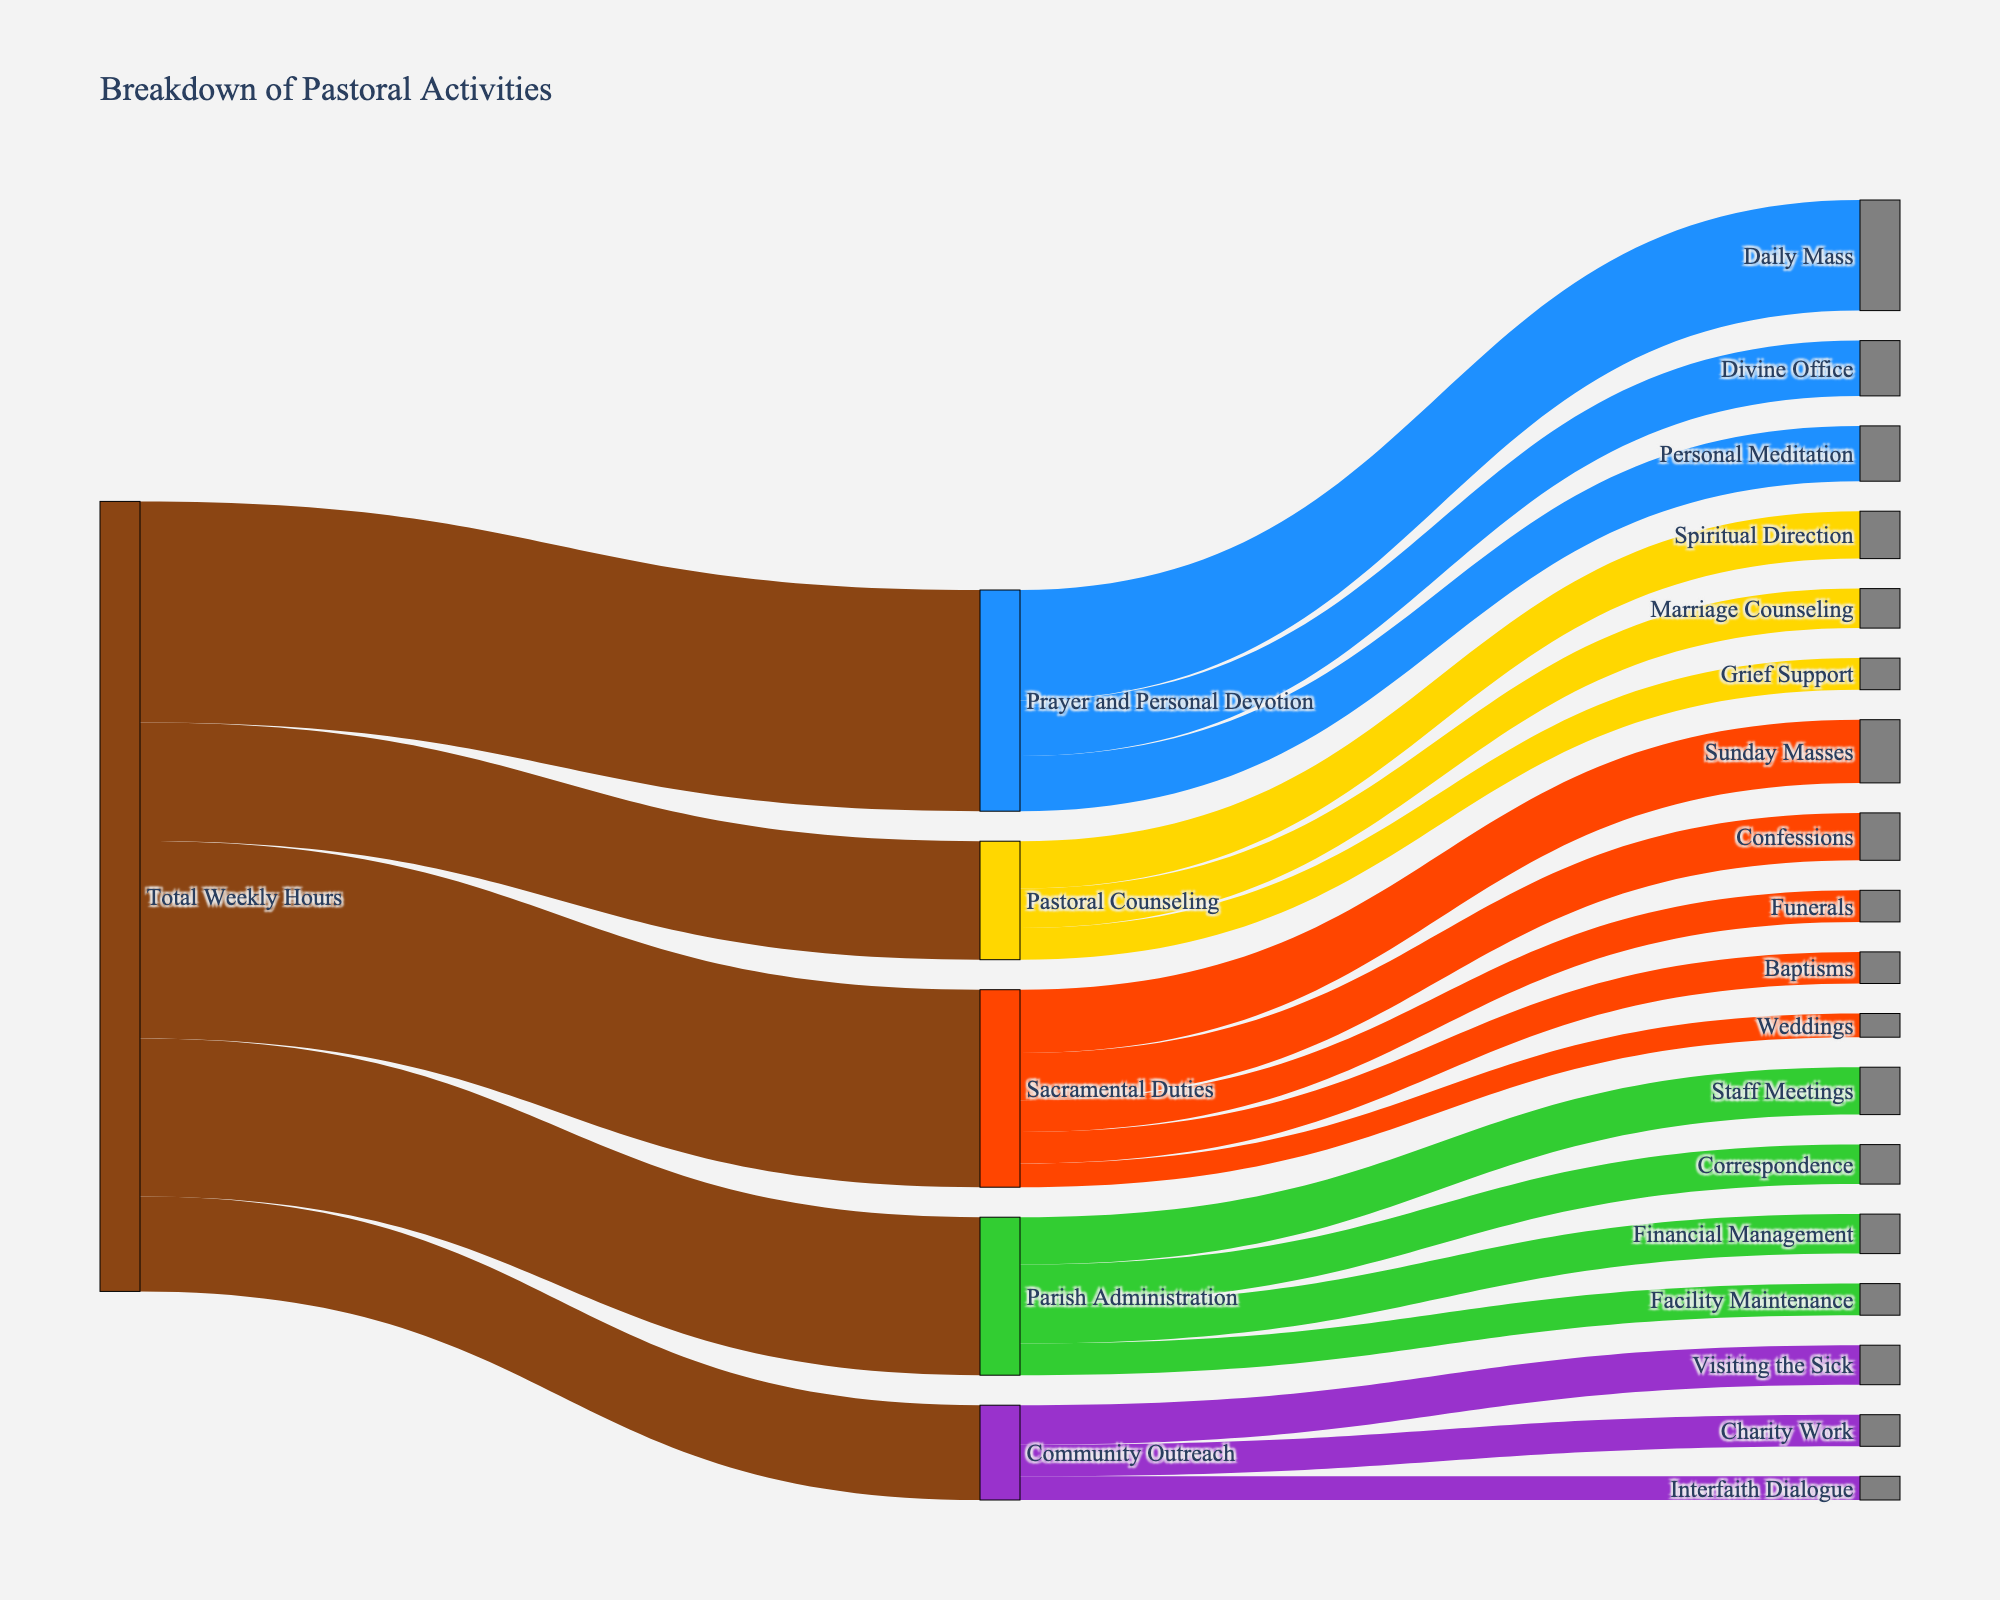What is the total amount of time spent on Prayer and Personal Devotion? According to the Sankey diagram, the Total Weekly Hours directed to Prayer and Personal Devotion is 28 hours.
Answer: 28 hours Which activity under Sacramental Duties takes the most time? In the Sankey diagram, Sunday Masses takes the most time under Sacramental Duties with 8 hours.
Answer: Sunday Masses How many hours are spent on Community Outreach activities in total? The times for Visiting the Sick, Charity Work, and Interfaith Dialogue are 5 hours, 4 hours, and 3 hours respectively. Summing these gives 5+4+3 = 12 hours.
Answer: 12 hours What is the total amount of time allocated to Parish Administration? The Sankey diagram indicates that the Total Weekly Hours going to Parish Administration is 20 hours.
Answer: 20 hours What is the relationship between the time spent on Daily Mass and Sunday Masses? By examining the Sankey diagram, the time spent on Daily Mass (14 hours) is greater than the time spent on Sunday Masses (8 hours).
Answer: Daily Mass > Sunday Masses Considering both Sacramental Duties and Parish Administration, which consumes more weekly hours? Sacramental Duties takes 25 hours while Parish Administration takes 20 hours. Therefore, Sacramental Duties consumes more weekly hours.
Answer: Sacramental Duties How many hours are spent on Financial Management in comparison to Facility Maintenance within Parish Administration? From the Sankey diagram, Financial Management gets 5 hours whereas Facility Maintenance gets 4 hours, so Financial Management takes 1 hour more.
Answer: Financial Management > Facility Maintenance What is the average time spent on each activity within Pastoral Counseling? The activities are Marriage Counseling (5 hours), Spiritual Direction (6 hours), and Grief Support (4 hours). The total is 5+6+4=15 hours. The average is 15/3 = 5 hours.
Answer: 5 hours Which activity under Community Outreach has the highest time allocation? Within Community Outreach, Visiting the Sick has the highest time allocation with 5 hours.
Answer: Visiting the Sick 